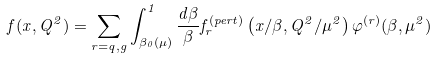Convert formula to latex. <formula><loc_0><loc_0><loc_500><loc_500>f ( x , Q ^ { 2 } ) = \sum _ { r = q , g } \int _ { \beta _ { 0 } ( \mu ) } ^ { 1 } \frac { d \beta } { \beta } f ^ { ( p e r t ) } _ { r } \left ( x / \beta , Q ^ { 2 } / \mu ^ { 2 } \right ) \varphi ^ { ( r ) } ( \beta , \mu ^ { 2 } )</formula> 